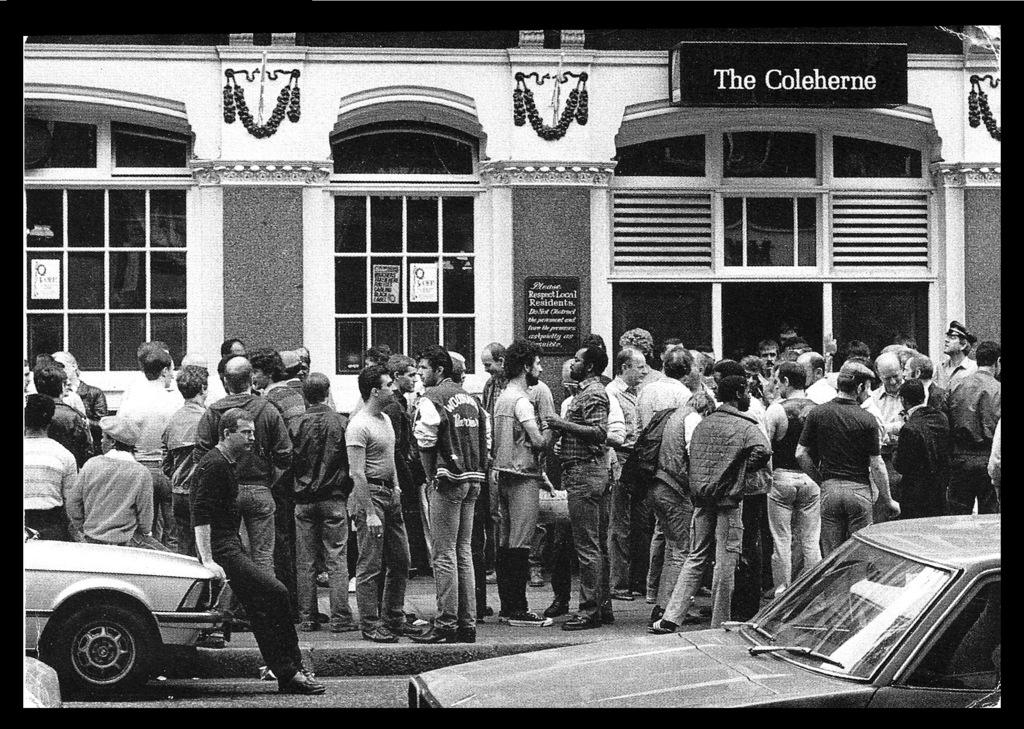What is the color scheme of the image? The image is black and white. What can be seen in the background of the image? There are people standing in front of a building. What type of vehicles are visible on the road? There are two cars on the road. Can you tell me how many frogs are hopping on the roof of the building in the image? There are no frogs present in the image; it features people standing in front of a building and two cars on the road. What type of crime is the crook committing in the image? There is no crook or crime depicted in the image; it shows people standing in front of a building and two cars on the road. 